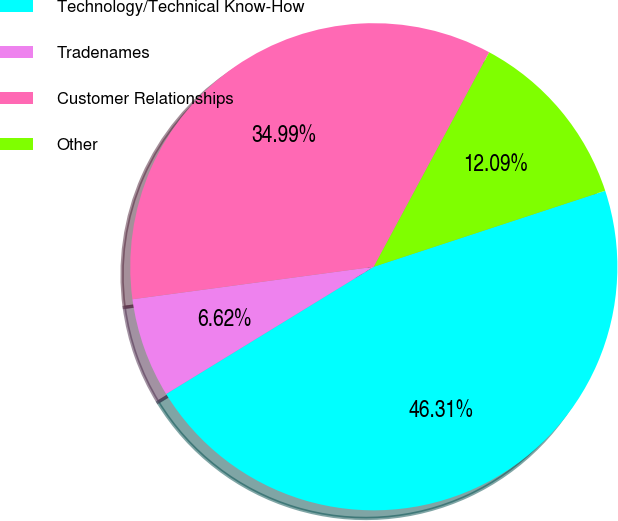Convert chart. <chart><loc_0><loc_0><loc_500><loc_500><pie_chart><fcel>Technology/Technical Know-How<fcel>Tradenames<fcel>Customer Relationships<fcel>Other<nl><fcel>46.31%<fcel>6.62%<fcel>34.99%<fcel>12.09%<nl></chart> 